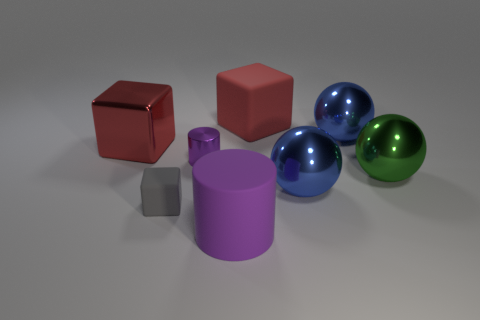Add 2 small purple things. How many objects exist? 10 Subtract all balls. How many objects are left? 5 Add 8 big metal cubes. How many big metal cubes exist? 9 Subtract 0 cyan spheres. How many objects are left? 8 Subtract all small cubes. Subtract all purple cylinders. How many objects are left? 5 Add 5 blue shiny things. How many blue shiny things are left? 7 